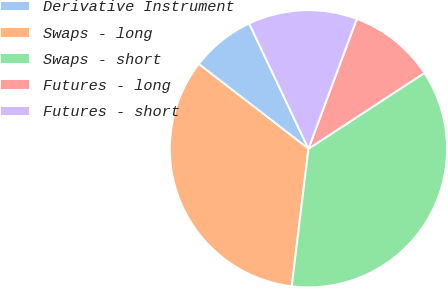<chart> <loc_0><loc_0><loc_500><loc_500><pie_chart><fcel>Derivative Instrument<fcel>Swaps - long<fcel>Swaps - short<fcel>Futures - long<fcel>Futures - short<nl><fcel>7.5%<fcel>33.54%<fcel>36.14%<fcel>10.11%<fcel>12.71%<nl></chart> 